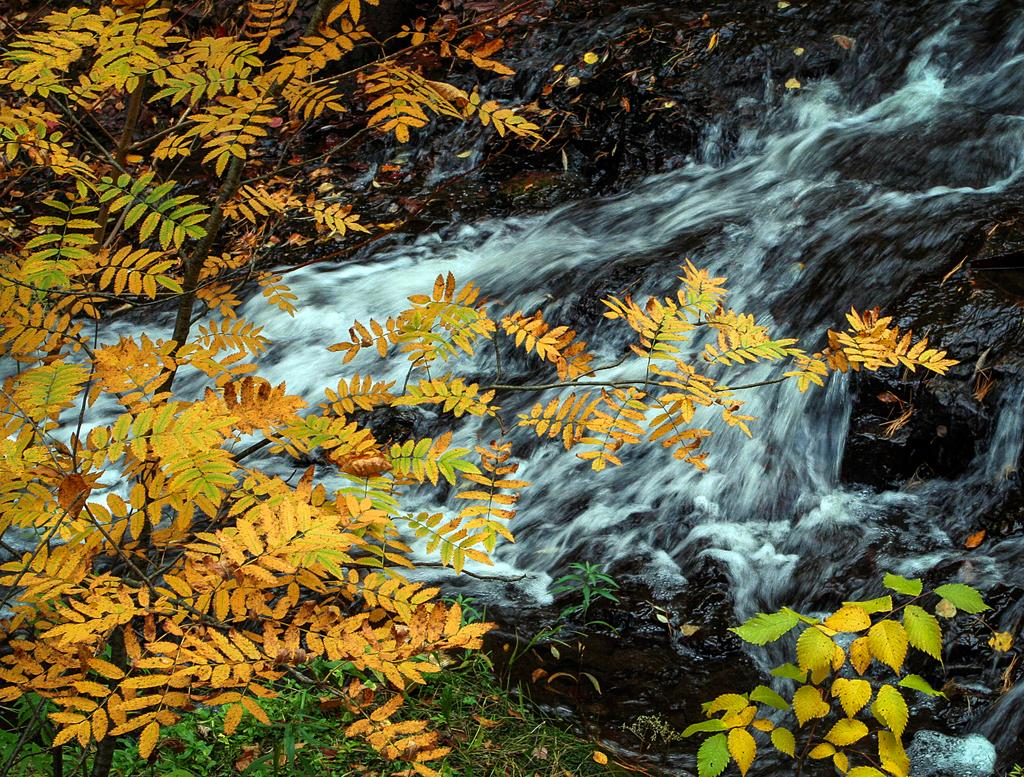What type of vegetation can be seen in the image? There are trees in the image. What is the source of the water in the image? The water is flowing from a rock in the image. What note is being played by the tree in the image? There is no indication that the tree is playing a note or making any sound in the image. 